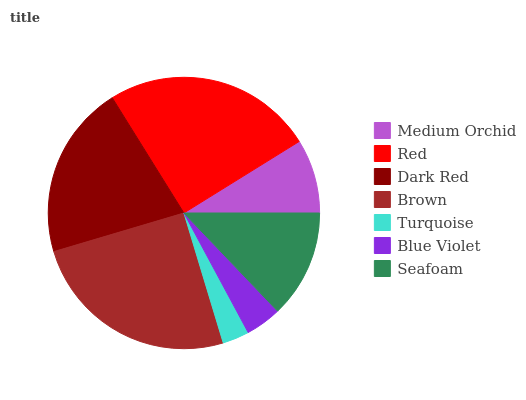Is Turquoise the minimum?
Answer yes or no. Yes. Is Brown the maximum?
Answer yes or no. Yes. Is Red the minimum?
Answer yes or no. No. Is Red the maximum?
Answer yes or no. No. Is Red greater than Medium Orchid?
Answer yes or no. Yes. Is Medium Orchid less than Red?
Answer yes or no. Yes. Is Medium Orchid greater than Red?
Answer yes or no. No. Is Red less than Medium Orchid?
Answer yes or no. No. Is Seafoam the high median?
Answer yes or no. Yes. Is Seafoam the low median?
Answer yes or no. Yes. Is Medium Orchid the high median?
Answer yes or no. No. Is Blue Violet the low median?
Answer yes or no. No. 